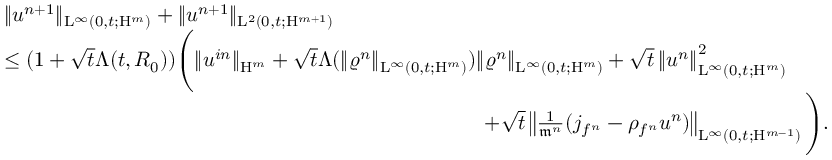<formula> <loc_0><loc_0><loc_500><loc_500>\begin{array} { r l } & { \| u ^ { n + 1 } \| _ { L ^ { \infty } ( 0 , t ; H ^ { m } ) } + \| u ^ { n + 1 } \| _ { L ^ { 2 } ( 0 , t ; H ^ { m + 1 } ) } } \\ & { \leq ( 1 + \sqrt { t } \Lambda ( t , R _ { 0 } ) ) \left ( \| u ^ { i n } \| _ { H ^ { m } } + \sqrt { t } \Lambda ( \| \varrho ^ { n } \| _ { L ^ { \infty } ( 0 , t ; H ^ { m } ) } ) \| \varrho ^ { n } \| _ { L ^ { \infty } ( 0 , t ; H ^ { m } ) } + \sqrt { t } \left \| u ^ { n } \right \| _ { L ^ { \infty } ( 0 , t ; H ^ { m } ) } ^ { 2 } } \\ & { \quad + \sqrt { t } \left \| \frac { 1 } { \mathfrak { m } ^ { n } } ( j _ { f ^ { n } } - \rho _ { f ^ { n } } u ^ { n } ) \right \| _ { L ^ { \infty } ( 0 , t ; H ^ { m - 1 } ) } \right ) . } \end{array}</formula> 